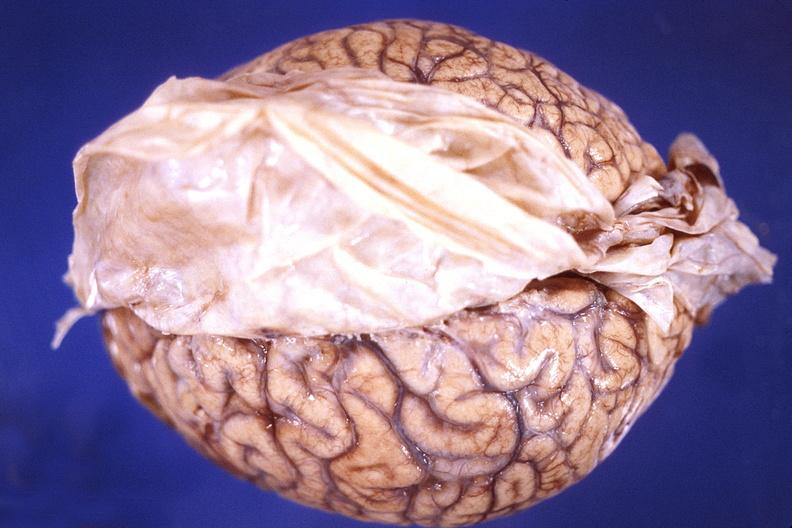does polysplenia show brain, cryptococcal meningitis?
Answer the question using a single word or phrase. No 